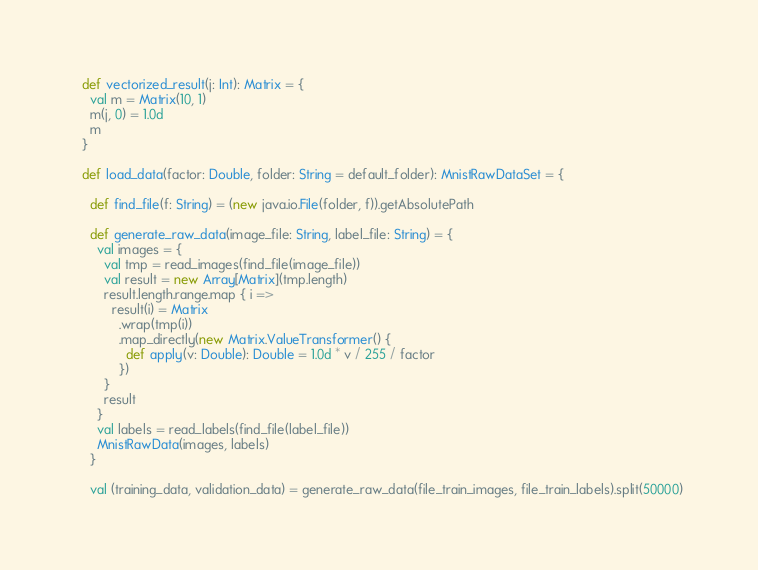Convert code to text. <code><loc_0><loc_0><loc_500><loc_500><_Scala_>  def vectorized_result(j: Int): Matrix = {
    val m = Matrix(10, 1)
    m(j, 0) = 1.0d
    m
  }

  def load_data(factor: Double, folder: String = default_folder): MnistRawDataSet = {

    def find_file(f: String) = (new java.io.File(folder, f)).getAbsolutePath

    def generate_raw_data(image_file: String, label_file: String) = {
      val images = {
        val tmp = read_images(find_file(image_file))
        val result = new Array[Matrix](tmp.length)
        result.length.range.map { i =>
          result(i) = Matrix
            .wrap(tmp(i))
            .map_directly(new Matrix.ValueTransformer() {
              def apply(v: Double): Double = 1.0d * v / 255 / factor
            })
        }
        result
      }
      val labels = read_labels(find_file(label_file))
      MnistRawData(images, labels)
    }

    val (training_data, validation_data) = generate_raw_data(file_train_images, file_train_labels).split(50000)</code> 